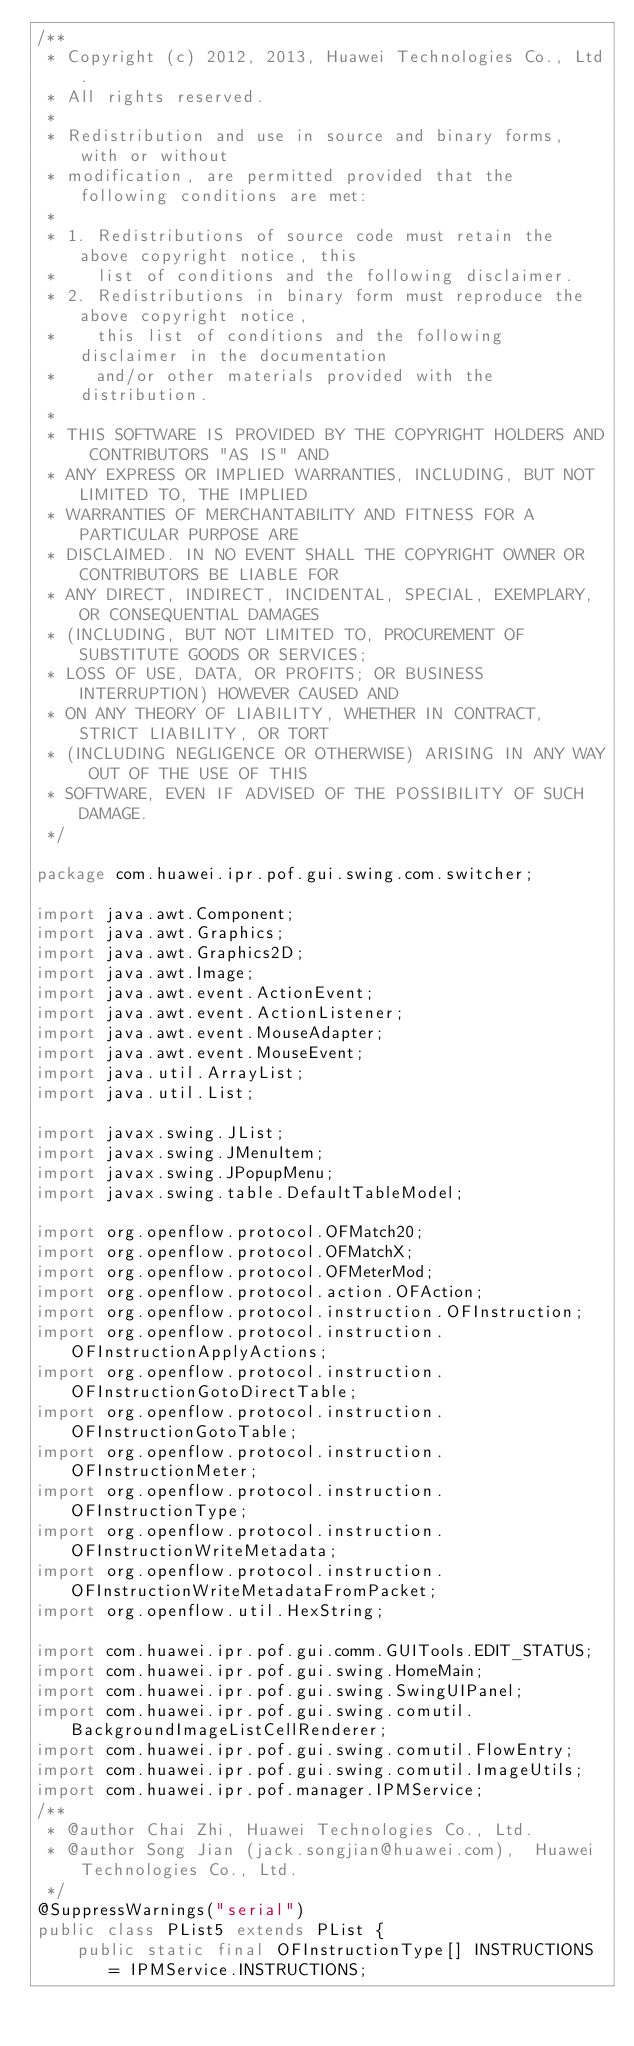<code> <loc_0><loc_0><loc_500><loc_500><_Java_>/**
 * Copyright (c) 2012, 2013, Huawei Technologies Co., Ltd.
 * All rights reserved.
 * 
 * Redistribution and use in source and binary forms, with or without
 * modification, are permitted provided that the following conditions are met: 
 * 
 * 1. Redistributions of source code must retain the above copyright notice, this
 *    list of conditions and the following disclaimer. 
 * 2. Redistributions in binary form must reproduce the above copyright notice,
 *    this list of conditions and the following disclaimer in the documentation
 *    and/or other materials provided with the distribution. 
 * 
 * THIS SOFTWARE IS PROVIDED BY THE COPYRIGHT HOLDERS AND CONTRIBUTORS "AS IS" AND
 * ANY EXPRESS OR IMPLIED WARRANTIES, INCLUDING, BUT NOT LIMITED TO, THE IMPLIED
 * WARRANTIES OF MERCHANTABILITY AND FITNESS FOR A PARTICULAR PURPOSE ARE
 * DISCLAIMED. IN NO EVENT SHALL THE COPYRIGHT OWNER OR CONTRIBUTORS BE LIABLE FOR
 * ANY DIRECT, INDIRECT, INCIDENTAL, SPECIAL, EXEMPLARY, OR CONSEQUENTIAL DAMAGES
 * (INCLUDING, BUT NOT LIMITED TO, PROCUREMENT OF SUBSTITUTE GOODS OR SERVICES;
 * LOSS OF USE, DATA, OR PROFITS; OR BUSINESS INTERRUPTION) HOWEVER CAUSED AND
 * ON ANY THEORY OF LIABILITY, WHETHER IN CONTRACT, STRICT LIABILITY, OR TORT
 * (INCLUDING NEGLIGENCE OR OTHERWISE) ARISING IN ANY WAY OUT OF THE USE OF THIS
 * SOFTWARE, EVEN IF ADVISED OF THE POSSIBILITY OF SUCH DAMAGE.
 */

package com.huawei.ipr.pof.gui.swing.com.switcher;

import java.awt.Component;
import java.awt.Graphics;
import java.awt.Graphics2D;
import java.awt.Image;
import java.awt.event.ActionEvent;
import java.awt.event.ActionListener;
import java.awt.event.MouseAdapter;
import java.awt.event.MouseEvent;
import java.util.ArrayList;
import java.util.List;

import javax.swing.JList;
import javax.swing.JMenuItem;
import javax.swing.JPopupMenu;
import javax.swing.table.DefaultTableModel;

import org.openflow.protocol.OFMatch20;
import org.openflow.protocol.OFMatchX;
import org.openflow.protocol.OFMeterMod;
import org.openflow.protocol.action.OFAction;
import org.openflow.protocol.instruction.OFInstruction;
import org.openflow.protocol.instruction.OFInstructionApplyActions;
import org.openflow.protocol.instruction.OFInstructionGotoDirectTable;
import org.openflow.protocol.instruction.OFInstructionGotoTable;
import org.openflow.protocol.instruction.OFInstructionMeter;
import org.openflow.protocol.instruction.OFInstructionType;
import org.openflow.protocol.instruction.OFInstructionWriteMetadata;
import org.openflow.protocol.instruction.OFInstructionWriteMetadataFromPacket;
import org.openflow.util.HexString;

import com.huawei.ipr.pof.gui.comm.GUITools.EDIT_STATUS;
import com.huawei.ipr.pof.gui.swing.HomeMain;
import com.huawei.ipr.pof.gui.swing.SwingUIPanel;
import com.huawei.ipr.pof.gui.swing.comutil.BackgroundImageListCellRenderer;
import com.huawei.ipr.pof.gui.swing.comutil.FlowEntry;
import com.huawei.ipr.pof.gui.swing.comutil.ImageUtils;
import com.huawei.ipr.pof.manager.IPMService;
/** 
 * @author Chai Zhi, Huawei Technologies Co., Ltd. 
 * @author Song Jian (jack.songjian@huawei.com),  Huawei Technologies Co., Ltd.
 */
@SuppressWarnings("serial")
public class PList5 extends PList {
	public static final OFInstructionType[] INSTRUCTIONS = IPMService.INSTRUCTIONS;
	</code> 